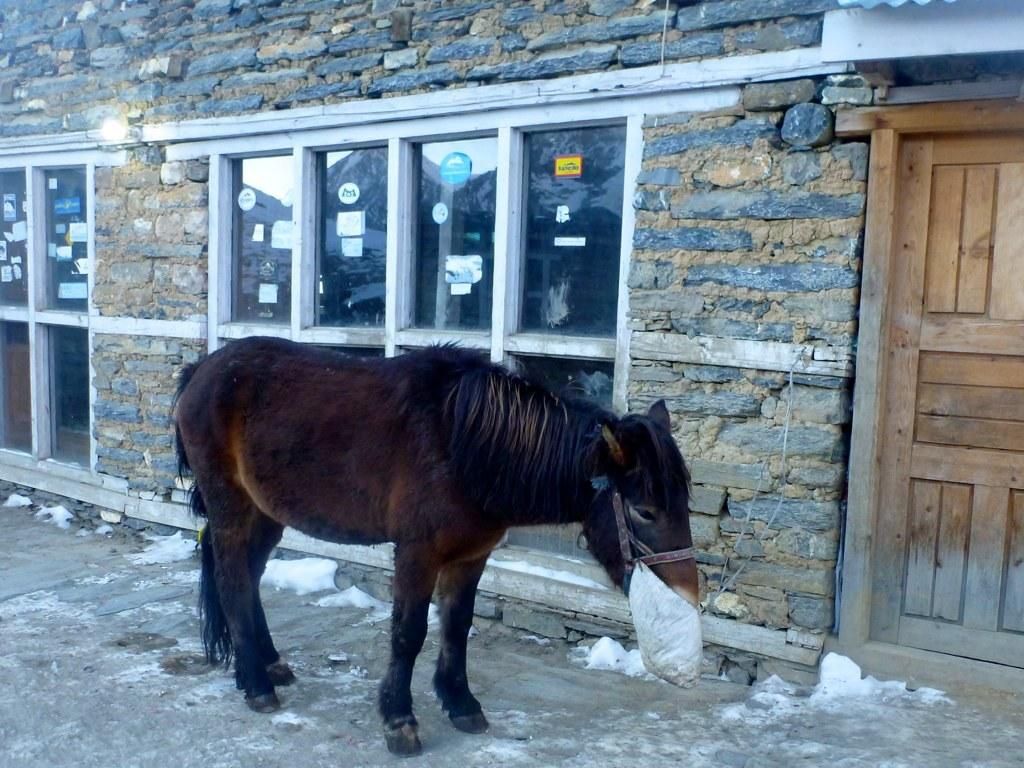What animal is standing on the walkway in the image? There is a horse standing on the walkway in the image. What can be seen in the background of the image? There is a wall, glass doors, stickers, and a wooden door in the background of the image. How does the scarecrow help to increase the horse's productivity in the image? There is no scarecrow present in the image, and therefore no such interaction can be observed. 